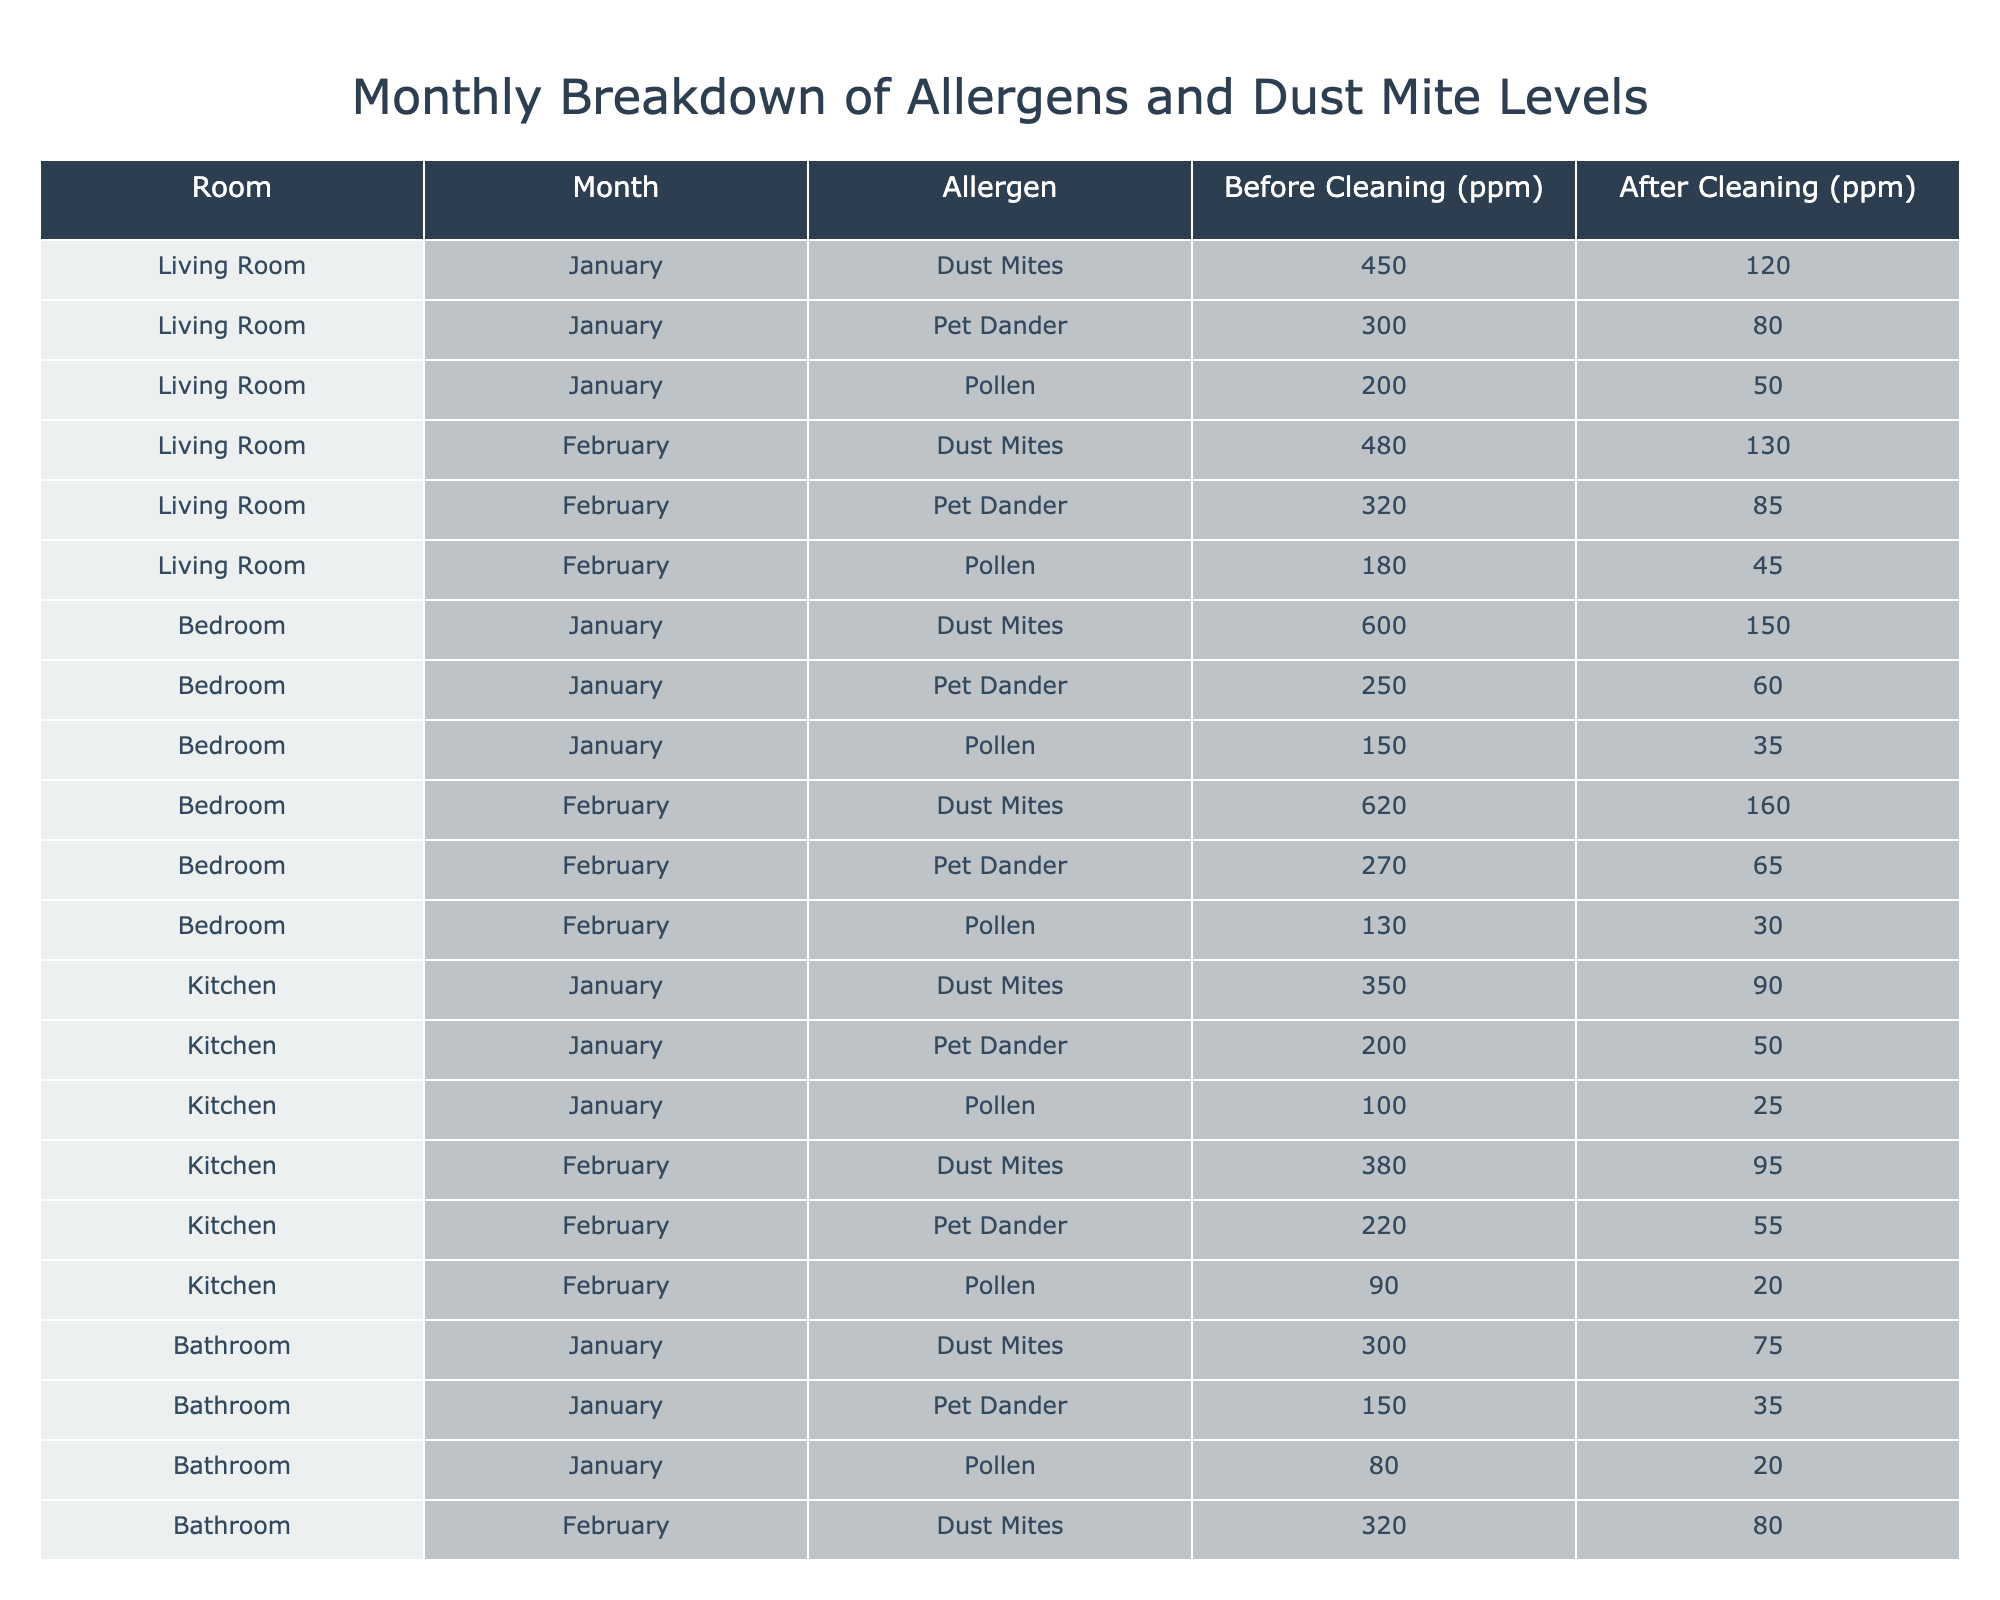What is the allergen level for dust mites in the living room before cleaning in January? The table shows that the level of dust mites in the living room before cleaning in January is listed as 450 ppm.
Answer: 450 ppm What was the allergen level for pet dander in the bedroom after cleaning in February? According to the table, the level of pet dander in the bedroom after cleaning in February is 65 ppm.
Answer: 65 ppm How much did the pollen level decrease in the living room from January to February after cleaning? In January, the pollen level in the living room was 50 ppm after cleaning, and in February it was also 45 ppm after cleaning. The decrease is 50 - 45 = 5 ppm.
Answer: 5 ppm What was the total allergen level for dust mites in the kitchen before cleaning in both January and February? The table shows the dust mite levels for the kitchen as 350 ppm in January and 380 ppm in February before cleaning. Adding these gives 350 + 380 = 730 ppm.
Answer: 730 ppm Is the pollen level in the bathroom lower after cleaning in February compared to January? In January, the pollen level in the bathroom after cleaning is 20 ppm, and in February it is 15 ppm. Since 15 is lower than 20, the statement is true.
Answer: Yes Which room had the highest level of dust mites before cleaning in January? The data shows that the bedroom had the highest dust mite level of 600 ppm in January, compared to the living room (450 ppm) and kitchen (350 ppm).
Answer: Bedroom What is the average level of pet dander in the living room and bedroom before cleaning in February? The pet dander level in the living room before cleaning in February is 320 ppm, and in the bedroom, it is 270 ppm. The average is (320 + 270)/2 = 295 ppm.
Answer: 295 ppm Did the dust mite levels in the bathroom get reduced to below 100 ppm after cleaning in both months? After cleaning, the dust mite levels in the bathroom were 75 ppm in January and 80 ppm in February. Both are below 100 ppm.
Answer: Yes What is the difference in allergen levels for pollen in the kitchen before and after cleaning in February? The pollen level before cleaning in February is 90 ppm, and after cleaning, it is 20 ppm. The difference is 90 - 20 = 70 ppm.
Answer: 70 ppm In which month did the bedroom have the highest overall allergen levels (sum of all allergens before cleaning)? In January, the bedroom had dust mites (600 ppm), pet dander (250 ppm), and pollen (150 ppm), totaling 600 + 250 + 150 = 1000 ppm. In February, it adds up to 620 + 270 + 130 = 1020 ppm. Therefore, the highest is in February.
Answer: February 